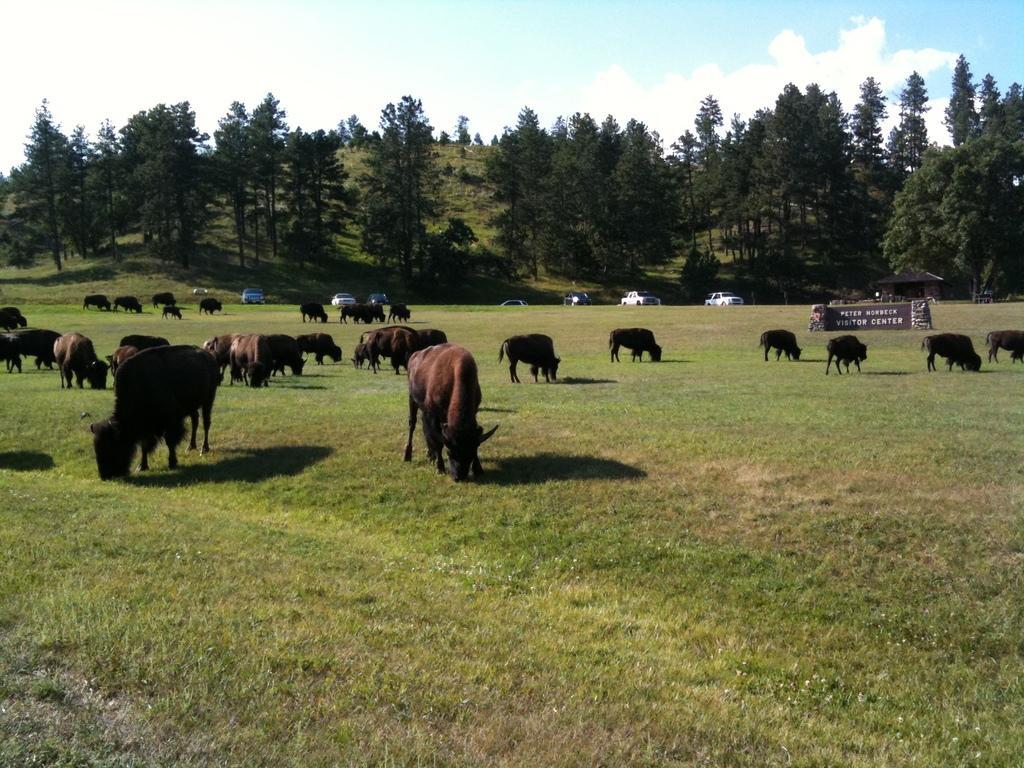Can you describe this image briefly? In this picture I can see the grass on which there are number of animals, which are of brown and black in color. On the right side of this picture I see a brown color thing on which there is something written. In the middle of this picture I see number of trees and few cars. In the background I see the sky. 